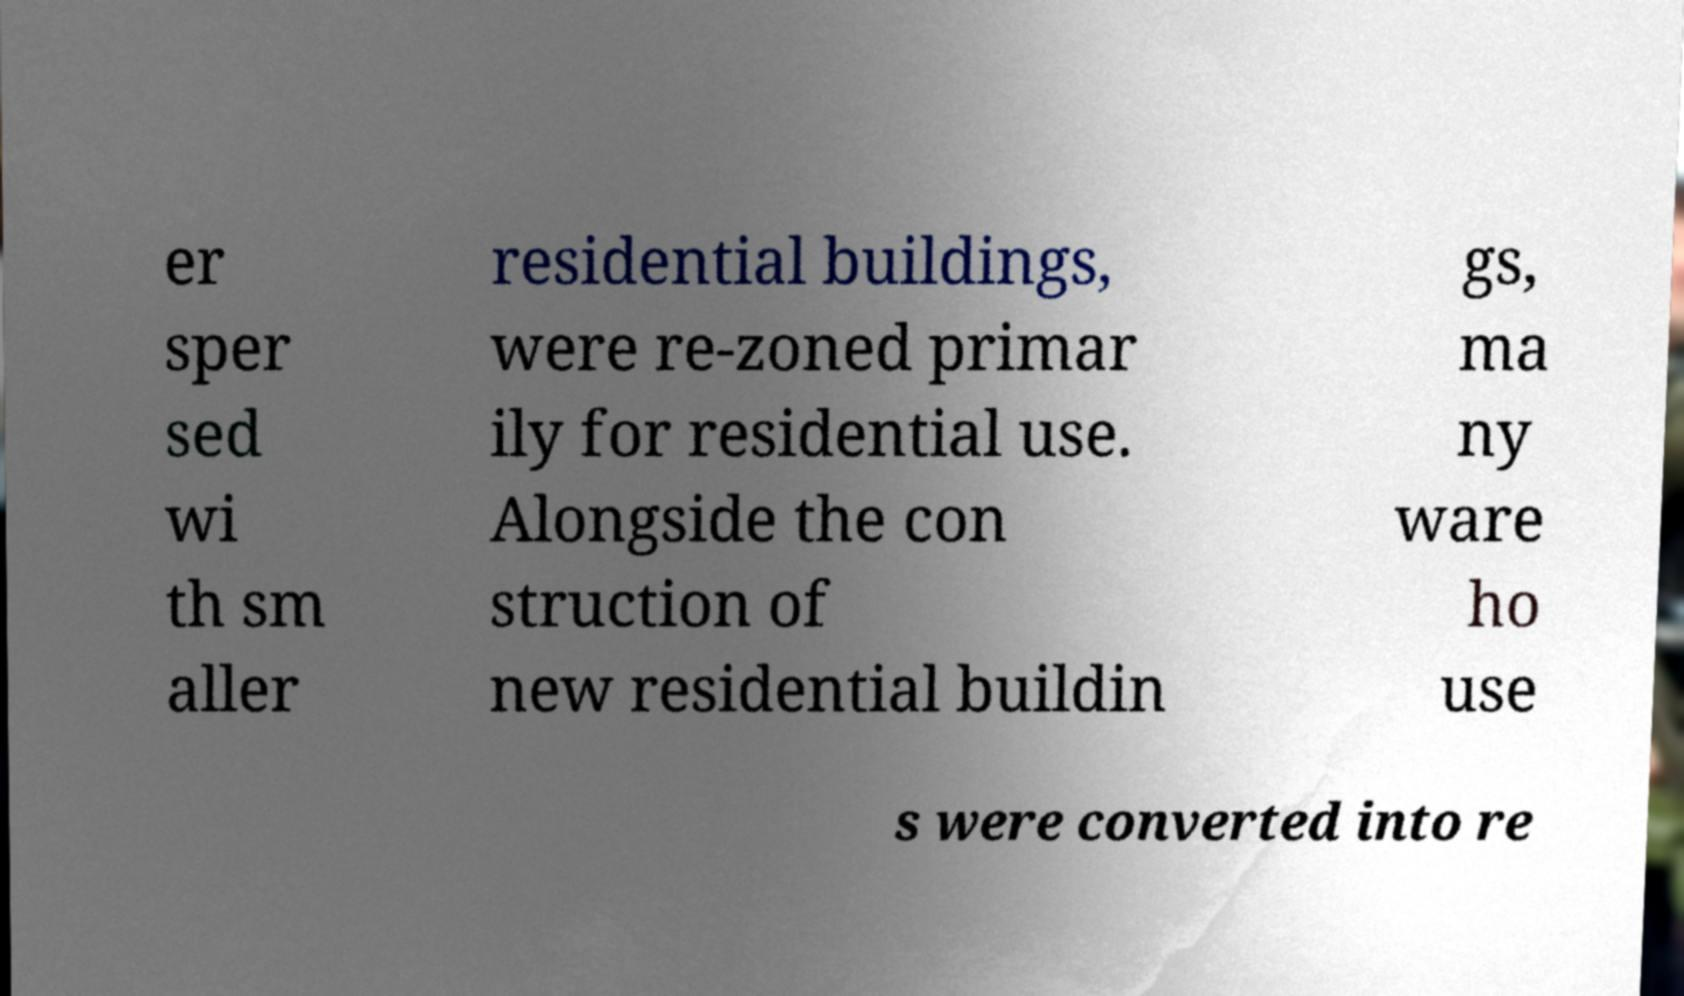Please read and relay the text visible in this image. What does it say? er sper sed wi th sm aller residential buildings, were re-zoned primar ily for residential use. Alongside the con struction of new residential buildin gs, ma ny ware ho use s were converted into re 